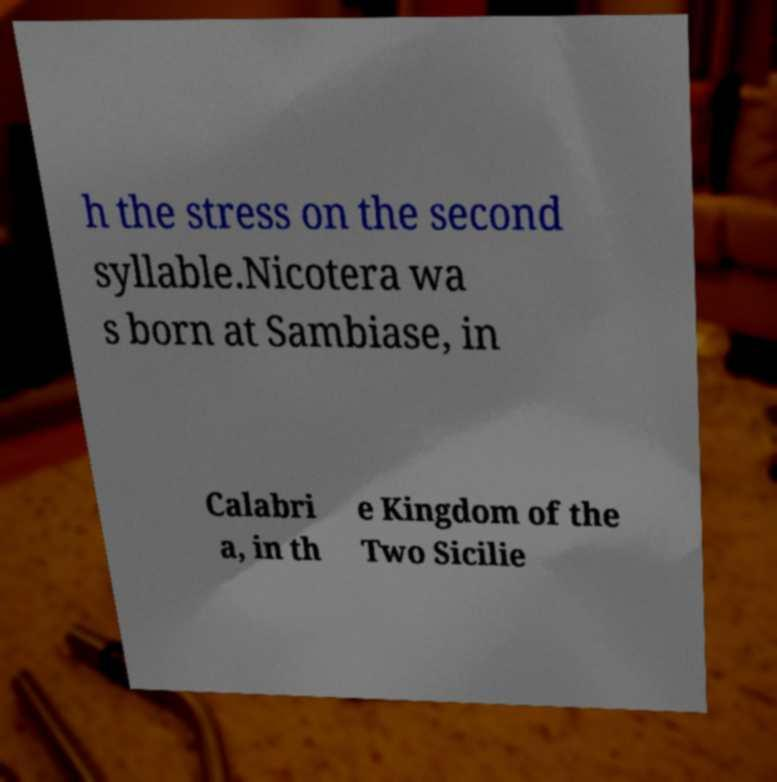Could you extract and type out the text from this image? h the stress on the second syllable.Nicotera wa s born at Sambiase, in Calabri a, in th e Kingdom of the Two Sicilie 